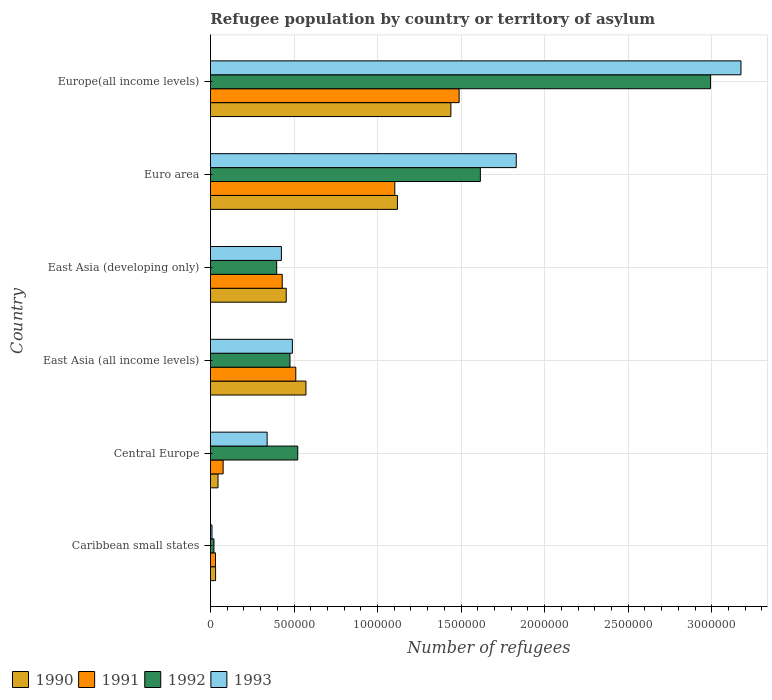Are the number of bars on each tick of the Y-axis equal?
Offer a very short reply. Yes. How many bars are there on the 2nd tick from the top?
Give a very brief answer. 4. What is the label of the 1st group of bars from the top?
Offer a terse response. Europe(all income levels). What is the number of refugees in 1992 in Caribbean small states?
Your answer should be very brief. 2.09e+04. Across all countries, what is the maximum number of refugees in 1991?
Make the answer very short. 1.49e+06. Across all countries, what is the minimum number of refugees in 1990?
Give a very brief answer. 3.07e+04. In which country was the number of refugees in 1990 maximum?
Keep it short and to the point. Europe(all income levels). In which country was the number of refugees in 1990 minimum?
Give a very brief answer. Caribbean small states. What is the total number of refugees in 1992 in the graph?
Ensure brevity in your answer.  6.02e+06. What is the difference between the number of refugees in 1993 in Central Europe and that in East Asia (all income levels)?
Offer a very short reply. -1.51e+05. What is the difference between the number of refugees in 1992 in Caribbean small states and the number of refugees in 1990 in East Asia (developing only)?
Ensure brevity in your answer.  -4.32e+05. What is the average number of refugees in 1991 per country?
Provide a short and direct response. 6.06e+05. What is the difference between the number of refugees in 1991 and number of refugees in 1993 in East Asia (developing only)?
Provide a short and direct response. 5099. What is the ratio of the number of refugees in 1990 in East Asia (all income levels) to that in Europe(all income levels)?
Your answer should be compact. 0.4. Is the difference between the number of refugees in 1991 in East Asia (developing only) and Euro area greater than the difference between the number of refugees in 1993 in East Asia (developing only) and Euro area?
Offer a very short reply. Yes. What is the difference between the highest and the second highest number of refugees in 1991?
Your answer should be compact. 3.85e+05. What is the difference between the highest and the lowest number of refugees in 1993?
Your answer should be compact. 3.17e+06. Is the sum of the number of refugees in 1993 in Central Europe and East Asia (developing only) greater than the maximum number of refugees in 1991 across all countries?
Provide a succinct answer. No. What does the 1st bar from the bottom in Europe(all income levels) represents?
Give a very brief answer. 1990. How many bars are there?
Provide a short and direct response. 24. Does the graph contain any zero values?
Provide a succinct answer. No. Does the graph contain grids?
Give a very brief answer. Yes. How many legend labels are there?
Offer a very short reply. 4. What is the title of the graph?
Keep it short and to the point. Refugee population by country or territory of asylum. What is the label or title of the X-axis?
Provide a succinct answer. Number of refugees. What is the label or title of the Y-axis?
Your answer should be compact. Country. What is the Number of refugees in 1990 in Caribbean small states?
Provide a succinct answer. 3.07e+04. What is the Number of refugees of 1991 in Caribbean small states?
Offer a terse response. 3.00e+04. What is the Number of refugees in 1992 in Caribbean small states?
Provide a short and direct response. 2.09e+04. What is the Number of refugees of 1993 in Caribbean small states?
Make the answer very short. 9084. What is the Number of refugees in 1990 in Central Europe?
Give a very brief answer. 4.51e+04. What is the Number of refugees in 1991 in Central Europe?
Offer a very short reply. 7.57e+04. What is the Number of refugees in 1992 in Central Europe?
Provide a succinct answer. 5.22e+05. What is the Number of refugees of 1993 in Central Europe?
Ensure brevity in your answer.  3.39e+05. What is the Number of refugees of 1990 in East Asia (all income levels)?
Give a very brief answer. 5.71e+05. What is the Number of refugees in 1991 in East Asia (all income levels)?
Your response must be concise. 5.11e+05. What is the Number of refugees in 1992 in East Asia (all income levels)?
Make the answer very short. 4.76e+05. What is the Number of refugees in 1993 in East Asia (all income levels)?
Your response must be concise. 4.90e+05. What is the Number of refugees in 1990 in East Asia (developing only)?
Provide a succinct answer. 4.53e+05. What is the Number of refugees of 1991 in East Asia (developing only)?
Give a very brief answer. 4.30e+05. What is the Number of refugees of 1992 in East Asia (developing only)?
Give a very brief answer. 3.96e+05. What is the Number of refugees in 1993 in East Asia (developing only)?
Provide a succinct answer. 4.24e+05. What is the Number of refugees of 1990 in Euro area?
Provide a short and direct response. 1.12e+06. What is the Number of refugees in 1991 in Euro area?
Your response must be concise. 1.10e+06. What is the Number of refugees in 1992 in Euro area?
Give a very brief answer. 1.62e+06. What is the Number of refugees in 1993 in Euro area?
Your response must be concise. 1.83e+06. What is the Number of refugees in 1990 in Europe(all income levels)?
Your answer should be compact. 1.44e+06. What is the Number of refugees in 1991 in Europe(all income levels)?
Your response must be concise. 1.49e+06. What is the Number of refugees in 1992 in Europe(all income levels)?
Your response must be concise. 2.99e+06. What is the Number of refugees of 1993 in Europe(all income levels)?
Give a very brief answer. 3.18e+06. Across all countries, what is the maximum Number of refugees of 1990?
Your answer should be very brief. 1.44e+06. Across all countries, what is the maximum Number of refugees of 1991?
Offer a terse response. 1.49e+06. Across all countries, what is the maximum Number of refugees of 1992?
Your response must be concise. 2.99e+06. Across all countries, what is the maximum Number of refugees in 1993?
Make the answer very short. 3.18e+06. Across all countries, what is the minimum Number of refugees in 1990?
Your response must be concise. 3.07e+04. Across all countries, what is the minimum Number of refugees in 1991?
Offer a very short reply. 3.00e+04. Across all countries, what is the minimum Number of refugees in 1992?
Your response must be concise. 2.09e+04. Across all countries, what is the minimum Number of refugees in 1993?
Your answer should be compact. 9084. What is the total Number of refugees in 1990 in the graph?
Offer a very short reply. 3.66e+06. What is the total Number of refugees in 1991 in the graph?
Keep it short and to the point. 3.64e+06. What is the total Number of refugees of 1992 in the graph?
Your answer should be very brief. 6.02e+06. What is the total Number of refugees of 1993 in the graph?
Ensure brevity in your answer.  6.27e+06. What is the difference between the Number of refugees in 1990 in Caribbean small states and that in Central Europe?
Ensure brevity in your answer.  -1.45e+04. What is the difference between the Number of refugees in 1991 in Caribbean small states and that in Central Europe?
Give a very brief answer. -4.58e+04. What is the difference between the Number of refugees in 1992 in Caribbean small states and that in Central Europe?
Your answer should be very brief. -5.02e+05. What is the difference between the Number of refugees of 1993 in Caribbean small states and that in Central Europe?
Provide a succinct answer. -3.30e+05. What is the difference between the Number of refugees of 1990 in Caribbean small states and that in East Asia (all income levels)?
Give a very brief answer. -5.41e+05. What is the difference between the Number of refugees in 1991 in Caribbean small states and that in East Asia (all income levels)?
Give a very brief answer. -4.81e+05. What is the difference between the Number of refugees in 1992 in Caribbean small states and that in East Asia (all income levels)?
Provide a short and direct response. -4.55e+05. What is the difference between the Number of refugees in 1993 in Caribbean small states and that in East Asia (all income levels)?
Your answer should be very brief. -4.81e+05. What is the difference between the Number of refugees of 1990 in Caribbean small states and that in East Asia (developing only)?
Offer a very short reply. -4.23e+05. What is the difference between the Number of refugees in 1991 in Caribbean small states and that in East Asia (developing only)?
Your response must be concise. -4.00e+05. What is the difference between the Number of refugees of 1992 in Caribbean small states and that in East Asia (developing only)?
Your answer should be compact. -3.75e+05. What is the difference between the Number of refugees in 1993 in Caribbean small states and that in East Asia (developing only)?
Your response must be concise. -4.15e+05. What is the difference between the Number of refugees of 1990 in Caribbean small states and that in Euro area?
Ensure brevity in your answer.  -1.09e+06. What is the difference between the Number of refugees of 1991 in Caribbean small states and that in Euro area?
Your answer should be compact. -1.07e+06. What is the difference between the Number of refugees of 1992 in Caribbean small states and that in Euro area?
Give a very brief answer. -1.59e+06. What is the difference between the Number of refugees of 1993 in Caribbean small states and that in Euro area?
Keep it short and to the point. -1.82e+06. What is the difference between the Number of refugees in 1990 in Caribbean small states and that in Europe(all income levels)?
Provide a succinct answer. -1.41e+06. What is the difference between the Number of refugees in 1991 in Caribbean small states and that in Europe(all income levels)?
Your response must be concise. -1.46e+06. What is the difference between the Number of refugees in 1992 in Caribbean small states and that in Europe(all income levels)?
Keep it short and to the point. -2.97e+06. What is the difference between the Number of refugees in 1993 in Caribbean small states and that in Europe(all income levels)?
Ensure brevity in your answer.  -3.17e+06. What is the difference between the Number of refugees of 1990 in Central Europe and that in East Asia (all income levels)?
Give a very brief answer. -5.26e+05. What is the difference between the Number of refugees of 1991 in Central Europe and that in East Asia (all income levels)?
Your answer should be compact. -4.35e+05. What is the difference between the Number of refugees in 1992 in Central Europe and that in East Asia (all income levels)?
Offer a very short reply. 4.66e+04. What is the difference between the Number of refugees in 1993 in Central Europe and that in East Asia (all income levels)?
Ensure brevity in your answer.  -1.51e+05. What is the difference between the Number of refugees in 1990 in Central Europe and that in East Asia (developing only)?
Offer a very short reply. -4.08e+05. What is the difference between the Number of refugees of 1991 in Central Europe and that in East Asia (developing only)?
Your answer should be very brief. -3.54e+05. What is the difference between the Number of refugees of 1992 in Central Europe and that in East Asia (developing only)?
Offer a terse response. 1.26e+05. What is the difference between the Number of refugees of 1993 in Central Europe and that in East Asia (developing only)?
Ensure brevity in your answer.  -8.53e+04. What is the difference between the Number of refugees in 1990 in Central Europe and that in Euro area?
Ensure brevity in your answer.  -1.07e+06. What is the difference between the Number of refugees in 1991 in Central Europe and that in Euro area?
Your response must be concise. -1.03e+06. What is the difference between the Number of refugees of 1992 in Central Europe and that in Euro area?
Your answer should be compact. -1.09e+06. What is the difference between the Number of refugees of 1993 in Central Europe and that in Euro area?
Your response must be concise. -1.49e+06. What is the difference between the Number of refugees of 1990 in Central Europe and that in Europe(all income levels)?
Offer a terse response. -1.39e+06. What is the difference between the Number of refugees in 1991 in Central Europe and that in Europe(all income levels)?
Your answer should be very brief. -1.41e+06. What is the difference between the Number of refugees of 1992 in Central Europe and that in Europe(all income levels)?
Make the answer very short. -2.47e+06. What is the difference between the Number of refugees in 1993 in Central Europe and that in Europe(all income levels)?
Keep it short and to the point. -2.84e+06. What is the difference between the Number of refugees of 1990 in East Asia (all income levels) and that in East Asia (developing only)?
Provide a short and direct response. 1.18e+05. What is the difference between the Number of refugees of 1991 in East Asia (all income levels) and that in East Asia (developing only)?
Your answer should be very brief. 8.11e+04. What is the difference between the Number of refugees in 1992 in East Asia (all income levels) and that in East Asia (developing only)?
Your answer should be very brief. 7.95e+04. What is the difference between the Number of refugees in 1993 in East Asia (all income levels) and that in East Asia (developing only)?
Offer a very short reply. 6.58e+04. What is the difference between the Number of refugees of 1990 in East Asia (all income levels) and that in Euro area?
Make the answer very short. -5.48e+05. What is the difference between the Number of refugees in 1991 in East Asia (all income levels) and that in Euro area?
Ensure brevity in your answer.  -5.93e+05. What is the difference between the Number of refugees in 1992 in East Asia (all income levels) and that in Euro area?
Your response must be concise. -1.14e+06. What is the difference between the Number of refugees in 1993 in East Asia (all income levels) and that in Euro area?
Give a very brief answer. -1.34e+06. What is the difference between the Number of refugees in 1990 in East Asia (all income levels) and that in Europe(all income levels)?
Ensure brevity in your answer.  -8.68e+05. What is the difference between the Number of refugees in 1991 in East Asia (all income levels) and that in Europe(all income levels)?
Provide a short and direct response. -9.78e+05. What is the difference between the Number of refugees of 1992 in East Asia (all income levels) and that in Europe(all income levels)?
Your answer should be compact. -2.52e+06. What is the difference between the Number of refugees of 1993 in East Asia (all income levels) and that in Europe(all income levels)?
Your response must be concise. -2.68e+06. What is the difference between the Number of refugees in 1990 in East Asia (developing only) and that in Euro area?
Provide a short and direct response. -6.66e+05. What is the difference between the Number of refugees of 1991 in East Asia (developing only) and that in Euro area?
Provide a succinct answer. -6.74e+05. What is the difference between the Number of refugees in 1992 in East Asia (developing only) and that in Euro area?
Give a very brief answer. -1.22e+06. What is the difference between the Number of refugees in 1993 in East Asia (developing only) and that in Euro area?
Your response must be concise. -1.41e+06. What is the difference between the Number of refugees of 1990 in East Asia (developing only) and that in Europe(all income levels)?
Provide a succinct answer. -9.86e+05. What is the difference between the Number of refugees in 1991 in East Asia (developing only) and that in Europe(all income levels)?
Your answer should be compact. -1.06e+06. What is the difference between the Number of refugees of 1992 in East Asia (developing only) and that in Europe(all income levels)?
Provide a short and direct response. -2.60e+06. What is the difference between the Number of refugees in 1993 in East Asia (developing only) and that in Europe(all income levels)?
Offer a terse response. -2.75e+06. What is the difference between the Number of refugees of 1990 in Euro area and that in Europe(all income levels)?
Your response must be concise. -3.20e+05. What is the difference between the Number of refugees of 1991 in Euro area and that in Europe(all income levels)?
Your answer should be compact. -3.85e+05. What is the difference between the Number of refugees in 1992 in Euro area and that in Europe(all income levels)?
Your answer should be very brief. -1.38e+06. What is the difference between the Number of refugees in 1993 in Euro area and that in Europe(all income levels)?
Ensure brevity in your answer.  -1.34e+06. What is the difference between the Number of refugees of 1990 in Caribbean small states and the Number of refugees of 1991 in Central Europe?
Offer a very short reply. -4.51e+04. What is the difference between the Number of refugees of 1990 in Caribbean small states and the Number of refugees of 1992 in Central Europe?
Ensure brevity in your answer.  -4.92e+05. What is the difference between the Number of refugees of 1990 in Caribbean small states and the Number of refugees of 1993 in Central Europe?
Your answer should be very brief. -3.09e+05. What is the difference between the Number of refugees of 1991 in Caribbean small states and the Number of refugees of 1992 in Central Europe?
Keep it short and to the point. -4.92e+05. What is the difference between the Number of refugees in 1991 in Caribbean small states and the Number of refugees in 1993 in Central Europe?
Your response must be concise. -3.09e+05. What is the difference between the Number of refugees in 1992 in Caribbean small states and the Number of refugees in 1993 in Central Europe?
Provide a succinct answer. -3.18e+05. What is the difference between the Number of refugees of 1990 in Caribbean small states and the Number of refugees of 1991 in East Asia (all income levels)?
Your answer should be compact. -4.80e+05. What is the difference between the Number of refugees of 1990 in Caribbean small states and the Number of refugees of 1992 in East Asia (all income levels)?
Offer a terse response. -4.45e+05. What is the difference between the Number of refugees in 1990 in Caribbean small states and the Number of refugees in 1993 in East Asia (all income levels)?
Give a very brief answer. -4.60e+05. What is the difference between the Number of refugees of 1991 in Caribbean small states and the Number of refugees of 1992 in East Asia (all income levels)?
Your answer should be compact. -4.46e+05. What is the difference between the Number of refugees in 1991 in Caribbean small states and the Number of refugees in 1993 in East Asia (all income levels)?
Your answer should be compact. -4.60e+05. What is the difference between the Number of refugees of 1992 in Caribbean small states and the Number of refugees of 1993 in East Asia (all income levels)?
Your answer should be compact. -4.69e+05. What is the difference between the Number of refugees of 1990 in Caribbean small states and the Number of refugees of 1991 in East Asia (developing only)?
Your answer should be compact. -3.99e+05. What is the difference between the Number of refugees in 1990 in Caribbean small states and the Number of refugees in 1992 in East Asia (developing only)?
Your response must be concise. -3.66e+05. What is the difference between the Number of refugees in 1990 in Caribbean small states and the Number of refugees in 1993 in East Asia (developing only)?
Ensure brevity in your answer.  -3.94e+05. What is the difference between the Number of refugees in 1991 in Caribbean small states and the Number of refugees in 1992 in East Asia (developing only)?
Offer a very short reply. -3.66e+05. What is the difference between the Number of refugees in 1991 in Caribbean small states and the Number of refugees in 1993 in East Asia (developing only)?
Make the answer very short. -3.94e+05. What is the difference between the Number of refugees in 1992 in Caribbean small states and the Number of refugees in 1993 in East Asia (developing only)?
Keep it short and to the point. -4.04e+05. What is the difference between the Number of refugees in 1990 in Caribbean small states and the Number of refugees in 1991 in Euro area?
Your answer should be very brief. -1.07e+06. What is the difference between the Number of refugees in 1990 in Caribbean small states and the Number of refugees in 1992 in Euro area?
Offer a very short reply. -1.58e+06. What is the difference between the Number of refugees in 1990 in Caribbean small states and the Number of refugees in 1993 in Euro area?
Offer a terse response. -1.80e+06. What is the difference between the Number of refugees of 1991 in Caribbean small states and the Number of refugees of 1992 in Euro area?
Your answer should be compact. -1.59e+06. What is the difference between the Number of refugees of 1991 in Caribbean small states and the Number of refugees of 1993 in Euro area?
Keep it short and to the point. -1.80e+06. What is the difference between the Number of refugees in 1992 in Caribbean small states and the Number of refugees in 1993 in Euro area?
Ensure brevity in your answer.  -1.81e+06. What is the difference between the Number of refugees in 1990 in Caribbean small states and the Number of refugees in 1991 in Europe(all income levels)?
Provide a succinct answer. -1.46e+06. What is the difference between the Number of refugees of 1990 in Caribbean small states and the Number of refugees of 1992 in Europe(all income levels)?
Offer a very short reply. -2.96e+06. What is the difference between the Number of refugees of 1990 in Caribbean small states and the Number of refugees of 1993 in Europe(all income levels)?
Your response must be concise. -3.14e+06. What is the difference between the Number of refugees in 1991 in Caribbean small states and the Number of refugees in 1992 in Europe(all income levels)?
Offer a very short reply. -2.96e+06. What is the difference between the Number of refugees in 1991 in Caribbean small states and the Number of refugees in 1993 in Europe(all income levels)?
Your answer should be very brief. -3.15e+06. What is the difference between the Number of refugees in 1992 in Caribbean small states and the Number of refugees in 1993 in Europe(all income levels)?
Your answer should be very brief. -3.15e+06. What is the difference between the Number of refugees in 1990 in Central Europe and the Number of refugees in 1991 in East Asia (all income levels)?
Ensure brevity in your answer.  -4.66e+05. What is the difference between the Number of refugees of 1990 in Central Europe and the Number of refugees of 1992 in East Asia (all income levels)?
Make the answer very short. -4.31e+05. What is the difference between the Number of refugees in 1990 in Central Europe and the Number of refugees in 1993 in East Asia (all income levels)?
Make the answer very short. -4.45e+05. What is the difference between the Number of refugees of 1991 in Central Europe and the Number of refugees of 1992 in East Asia (all income levels)?
Offer a very short reply. -4.00e+05. What is the difference between the Number of refugees of 1991 in Central Europe and the Number of refugees of 1993 in East Asia (all income levels)?
Make the answer very short. -4.15e+05. What is the difference between the Number of refugees in 1992 in Central Europe and the Number of refugees in 1993 in East Asia (all income levels)?
Make the answer very short. 3.21e+04. What is the difference between the Number of refugees in 1990 in Central Europe and the Number of refugees in 1991 in East Asia (developing only)?
Make the answer very short. -3.84e+05. What is the difference between the Number of refugees in 1990 in Central Europe and the Number of refugees in 1992 in East Asia (developing only)?
Your answer should be very brief. -3.51e+05. What is the difference between the Number of refugees of 1990 in Central Europe and the Number of refugees of 1993 in East Asia (developing only)?
Keep it short and to the point. -3.79e+05. What is the difference between the Number of refugees of 1991 in Central Europe and the Number of refugees of 1992 in East Asia (developing only)?
Provide a short and direct response. -3.21e+05. What is the difference between the Number of refugees of 1991 in Central Europe and the Number of refugees of 1993 in East Asia (developing only)?
Your response must be concise. -3.49e+05. What is the difference between the Number of refugees in 1992 in Central Europe and the Number of refugees in 1993 in East Asia (developing only)?
Keep it short and to the point. 9.79e+04. What is the difference between the Number of refugees of 1990 in Central Europe and the Number of refugees of 1991 in Euro area?
Offer a very short reply. -1.06e+06. What is the difference between the Number of refugees in 1990 in Central Europe and the Number of refugees in 1992 in Euro area?
Your answer should be compact. -1.57e+06. What is the difference between the Number of refugees in 1990 in Central Europe and the Number of refugees in 1993 in Euro area?
Provide a short and direct response. -1.78e+06. What is the difference between the Number of refugees in 1991 in Central Europe and the Number of refugees in 1992 in Euro area?
Make the answer very short. -1.54e+06. What is the difference between the Number of refugees of 1991 in Central Europe and the Number of refugees of 1993 in Euro area?
Make the answer very short. -1.75e+06. What is the difference between the Number of refugees of 1992 in Central Europe and the Number of refugees of 1993 in Euro area?
Ensure brevity in your answer.  -1.31e+06. What is the difference between the Number of refugees of 1990 in Central Europe and the Number of refugees of 1991 in Europe(all income levels)?
Provide a short and direct response. -1.44e+06. What is the difference between the Number of refugees of 1990 in Central Europe and the Number of refugees of 1992 in Europe(all income levels)?
Offer a very short reply. -2.95e+06. What is the difference between the Number of refugees in 1990 in Central Europe and the Number of refugees in 1993 in Europe(all income levels)?
Your response must be concise. -3.13e+06. What is the difference between the Number of refugees in 1991 in Central Europe and the Number of refugees in 1992 in Europe(all income levels)?
Provide a succinct answer. -2.92e+06. What is the difference between the Number of refugees in 1991 in Central Europe and the Number of refugees in 1993 in Europe(all income levels)?
Provide a short and direct response. -3.10e+06. What is the difference between the Number of refugees in 1992 in Central Europe and the Number of refugees in 1993 in Europe(all income levels)?
Offer a terse response. -2.65e+06. What is the difference between the Number of refugees of 1990 in East Asia (all income levels) and the Number of refugees of 1991 in East Asia (developing only)?
Your response must be concise. 1.42e+05. What is the difference between the Number of refugees of 1990 in East Asia (all income levels) and the Number of refugees of 1992 in East Asia (developing only)?
Your answer should be very brief. 1.75e+05. What is the difference between the Number of refugees of 1990 in East Asia (all income levels) and the Number of refugees of 1993 in East Asia (developing only)?
Your answer should be very brief. 1.47e+05. What is the difference between the Number of refugees of 1991 in East Asia (all income levels) and the Number of refugees of 1992 in East Asia (developing only)?
Offer a very short reply. 1.14e+05. What is the difference between the Number of refugees of 1991 in East Asia (all income levels) and the Number of refugees of 1993 in East Asia (developing only)?
Your answer should be very brief. 8.62e+04. What is the difference between the Number of refugees of 1992 in East Asia (all income levels) and the Number of refugees of 1993 in East Asia (developing only)?
Provide a succinct answer. 5.14e+04. What is the difference between the Number of refugees of 1990 in East Asia (all income levels) and the Number of refugees of 1991 in Euro area?
Offer a very short reply. -5.32e+05. What is the difference between the Number of refugees in 1990 in East Asia (all income levels) and the Number of refugees in 1992 in Euro area?
Make the answer very short. -1.04e+06. What is the difference between the Number of refugees in 1990 in East Asia (all income levels) and the Number of refugees in 1993 in Euro area?
Ensure brevity in your answer.  -1.26e+06. What is the difference between the Number of refugees in 1991 in East Asia (all income levels) and the Number of refugees in 1992 in Euro area?
Give a very brief answer. -1.10e+06. What is the difference between the Number of refugees of 1991 in East Asia (all income levels) and the Number of refugees of 1993 in Euro area?
Your answer should be compact. -1.32e+06. What is the difference between the Number of refugees in 1992 in East Asia (all income levels) and the Number of refugees in 1993 in Euro area?
Make the answer very short. -1.35e+06. What is the difference between the Number of refugees of 1990 in East Asia (all income levels) and the Number of refugees of 1991 in Europe(all income levels)?
Your answer should be very brief. -9.17e+05. What is the difference between the Number of refugees in 1990 in East Asia (all income levels) and the Number of refugees in 1992 in Europe(all income levels)?
Offer a terse response. -2.42e+06. What is the difference between the Number of refugees of 1990 in East Asia (all income levels) and the Number of refugees of 1993 in Europe(all income levels)?
Provide a short and direct response. -2.60e+06. What is the difference between the Number of refugees of 1991 in East Asia (all income levels) and the Number of refugees of 1992 in Europe(all income levels)?
Offer a terse response. -2.48e+06. What is the difference between the Number of refugees of 1991 in East Asia (all income levels) and the Number of refugees of 1993 in Europe(all income levels)?
Your response must be concise. -2.66e+06. What is the difference between the Number of refugees in 1992 in East Asia (all income levels) and the Number of refugees in 1993 in Europe(all income levels)?
Keep it short and to the point. -2.70e+06. What is the difference between the Number of refugees in 1990 in East Asia (developing only) and the Number of refugees in 1991 in Euro area?
Offer a very short reply. -6.50e+05. What is the difference between the Number of refugees in 1990 in East Asia (developing only) and the Number of refugees in 1992 in Euro area?
Keep it short and to the point. -1.16e+06. What is the difference between the Number of refugees of 1990 in East Asia (developing only) and the Number of refugees of 1993 in Euro area?
Keep it short and to the point. -1.38e+06. What is the difference between the Number of refugees of 1991 in East Asia (developing only) and the Number of refugees of 1992 in Euro area?
Provide a short and direct response. -1.19e+06. What is the difference between the Number of refugees in 1991 in East Asia (developing only) and the Number of refugees in 1993 in Euro area?
Give a very brief answer. -1.40e+06. What is the difference between the Number of refugees in 1992 in East Asia (developing only) and the Number of refugees in 1993 in Euro area?
Make the answer very short. -1.43e+06. What is the difference between the Number of refugees of 1990 in East Asia (developing only) and the Number of refugees of 1991 in Europe(all income levels)?
Your response must be concise. -1.03e+06. What is the difference between the Number of refugees in 1990 in East Asia (developing only) and the Number of refugees in 1992 in Europe(all income levels)?
Provide a succinct answer. -2.54e+06. What is the difference between the Number of refugees of 1990 in East Asia (developing only) and the Number of refugees of 1993 in Europe(all income levels)?
Ensure brevity in your answer.  -2.72e+06. What is the difference between the Number of refugees in 1991 in East Asia (developing only) and the Number of refugees in 1992 in Europe(all income levels)?
Give a very brief answer. -2.56e+06. What is the difference between the Number of refugees of 1991 in East Asia (developing only) and the Number of refugees of 1993 in Europe(all income levels)?
Your response must be concise. -2.75e+06. What is the difference between the Number of refugees in 1992 in East Asia (developing only) and the Number of refugees in 1993 in Europe(all income levels)?
Provide a succinct answer. -2.78e+06. What is the difference between the Number of refugees in 1990 in Euro area and the Number of refugees in 1991 in Europe(all income levels)?
Offer a terse response. -3.69e+05. What is the difference between the Number of refugees of 1990 in Euro area and the Number of refugees of 1992 in Europe(all income levels)?
Make the answer very short. -1.87e+06. What is the difference between the Number of refugees in 1990 in Euro area and the Number of refugees in 1993 in Europe(all income levels)?
Your response must be concise. -2.06e+06. What is the difference between the Number of refugees of 1991 in Euro area and the Number of refugees of 1992 in Europe(all income levels)?
Offer a very short reply. -1.89e+06. What is the difference between the Number of refugees in 1991 in Euro area and the Number of refugees in 1993 in Europe(all income levels)?
Your answer should be very brief. -2.07e+06. What is the difference between the Number of refugees of 1992 in Euro area and the Number of refugees of 1993 in Europe(all income levels)?
Keep it short and to the point. -1.56e+06. What is the average Number of refugees in 1990 per country?
Make the answer very short. 6.10e+05. What is the average Number of refugees in 1991 per country?
Keep it short and to the point. 6.06e+05. What is the average Number of refugees in 1992 per country?
Give a very brief answer. 1.00e+06. What is the average Number of refugees of 1993 per country?
Make the answer very short. 1.04e+06. What is the difference between the Number of refugees in 1990 and Number of refugees in 1991 in Caribbean small states?
Offer a terse response. 684. What is the difference between the Number of refugees in 1990 and Number of refugees in 1992 in Caribbean small states?
Your answer should be very brief. 9790. What is the difference between the Number of refugees in 1990 and Number of refugees in 1993 in Caribbean small states?
Keep it short and to the point. 2.16e+04. What is the difference between the Number of refugees of 1991 and Number of refugees of 1992 in Caribbean small states?
Ensure brevity in your answer.  9106. What is the difference between the Number of refugees of 1991 and Number of refugees of 1993 in Caribbean small states?
Offer a very short reply. 2.09e+04. What is the difference between the Number of refugees of 1992 and Number of refugees of 1993 in Caribbean small states?
Provide a succinct answer. 1.18e+04. What is the difference between the Number of refugees in 1990 and Number of refugees in 1991 in Central Europe?
Your answer should be very brief. -3.06e+04. What is the difference between the Number of refugees of 1990 and Number of refugees of 1992 in Central Europe?
Give a very brief answer. -4.77e+05. What is the difference between the Number of refugees of 1990 and Number of refugees of 1993 in Central Europe?
Make the answer very short. -2.94e+05. What is the difference between the Number of refugees of 1991 and Number of refugees of 1992 in Central Europe?
Make the answer very short. -4.47e+05. What is the difference between the Number of refugees of 1991 and Number of refugees of 1993 in Central Europe?
Offer a terse response. -2.63e+05. What is the difference between the Number of refugees in 1992 and Number of refugees in 1993 in Central Europe?
Ensure brevity in your answer.  1.83e+05. What is the difference between the Number of refugees in 1990 and Number of refugees in 1991 in East Asia (all income levels)?
Give a very brief answer. 6.08e+04. What is the difference between the Number of refugees of 1990 and Number of refugees of 1992 in East Asia (all income levels)?
Your response must be concise. 9.57e+04. What is the difference between the Number of refugees of 1990 and Number of refugees of 1993 in East Asia (all income levels)?
Give a very brief answer. 8.12e+04. What is the difference between the Number of refugees of 1991 and Number of refugees of 1992 in East Asia (all income levels)?
Offer a very short reply. 3.49e+04. What is the difference between the Number of refugees of 1991 and Number of refugees of 1993 in East Asia (all income levels)?
Keep it short and to the point. 2.04e+04. What is the difference between the Number of refugees of 1992 and Number of refugees of 1993 in East Asia (all income levels)?
Ensure brevity in your answer.  -1.44e+04. What is the difference between the Number of refugees in 1990 and Number of refugees in 1991 in East Asia (developing only)?
Ensure brevity in your answer.  2.38e+04. What is the difference between the Number of refugees of 1990 and Number of refugees of 1992 in East Asia (developing only)?
Ensure brevity in your answer.  5.70e+04. What is the difference between the Number of refugees of 1990 and Number of refugees of 1993 in East Asia (developing only)?
Offer a terse response. 2.89e+04. What is the difference between the Number of refugees in 1991 and Number of refugees in 1992 in East Asia (developing only)?
Offer a terse response. 3.32e+04. What is the difference between the Number of refugees of 1991 and Number of refugees of 1993 in East Asia (developing only)?
Make the answer very short. 5099. What is the difference between the Number of refugees in 1992 and Number of refugees in 1993 in East Asia (developing only)?
Provide a short and direct response. -2.81e+04. What is the difference between the Number of refugees in 1990 and Number of refugees in 1991 in Euro area?
Your response must be concise. 1.58e+04. What is the difference between the Number of refugees of 1990 and Number of refugees of 1992 in Euro area?
Ensure brevity in your answer.  -4.96e+05. What is the difference between the Number of refugees of 1990 and Number of refugees of 1993 in Euro area?
Your answer should be compact. -7.11e+05. What is the difference between the Number of refugees in 1991 and Number of refugees in 1992 in Euro area?
Provide a short and direct response. -5.12e+05. What is the difference between the Number of refugees of 1991 and Number of refugees of 1993 in Euro area?
Give a very brief answer. -7.27e+05. What is the difference between the Number of refugees in 1992 and Number of refugees in 1993 in Euro area?
Offer a very short reply. -2.15e+05. What is the difference between the Number of refugees in 1990 and Number of refugees in 1991 in Europe(all income levels)?
Offer a terse response. -4.92e+04. What is the difference between the Number of refugees of 1990 and Number of refugees of 1992 in Europe(all income levels)?
Make the answer very short. -1.55e+06. What is the difference between the Number of refugees in 1990 and Number of refugees in 1993 in Europe(all income levels)?
Offer a very short reply. -1.74e+06. What is the difference between the Number of refugees of 1991 and Number of refugees of 1992 in Europe(all income levels)?
Your answer should be compact. -1.50e+06. What is the difference between the Number of refugees of 1991 and Number of refugees of 1993 in Europe(all income levels)?
Make the answer very short. -1.69e+06. What is the difference between the Number of refugees of 1992 and Number of refugees of 1993 in Europe(all income levels)?
Ensure brevity in your answer.  -1.82e+05. What is the ratio of the Number of refugees of 1990 in Caribbean small states to that in Central Europe?
Ensure brevity in your answer.  0.68. What is the ratio of the Number of refugees of 1991 in Caribbean small states to that in Central Europe?
Give a very brief answer. 0.4. What is the ratio of the Number of refugees in 1992 in Caribbean small states to that in Central Europe?
Your answer should be very brief. 0.04. What is the ratio of the Number of refugees in 1993 in Caribbean small states to that in Central Europe?
Your answer should be compact. 0.03. What is the ratio of the Number of refugees of 1990 in Caribbean small states to that in East Asia (all income levels)?
Offer a terse response. 0.05. What is the ratio of the Number of refugees of 1991 in Caribbean small states to that in East Asia (all income levels)?
Your response must be concise. 0.06. What is the ratio of the Number of refugees of 1992 in Caribbean small states to that in East Asia (all income levels)?
Your answer should be compact. 0.04. What is the ratio of the Number of refugees in 1993 in Caribbean small states to that in East Asia (all income levels)?
Give a very brief answer. 0.02. What is the ratio of the Number of refugees of 1990 in Caribbean small states to that in East Asia (developing only)?
Your answer should be compact. 0.07. What is the ratio of the Number of refugees of 1991 in Caribbean small states to that in East Asia (developing only)?
Offer a very short reply. 0.07. What is the ratio of the Number of refugees of 1992 in Caribbean small states to that in East Asia (developing only)?
Make the answer very short. 0.05. What is the ratio of the Number of refugees in 1993 in Caribbean small states to that in East Asia (developing only)?
Give a very brief answer. 0.02. What is the ratio of the Number of refugees in 1990 in Caribbean small states to that in Euro area?
Your answer should be compact. 0.03. What is the ratio of the Number of refugees in 1991 in Caribbean small states to that in Euro area?
Your response must be concise. 0.03. What is the ratio of the Number of refugees in 1992 in Caribbean small states to that in Euro area?
Make the answer very short. 0.01. What is the ratio of the Number of refugees of 1993 in Caribbean small states to that in Euro area?
Your answer should be compact. 0.01. What is the ratio of the Number of refugees of 1990 in Caribbean small states to that in Europe(all income levels)?
Make the answer very short. 0.02. What is the ratio of the Number of refugees in 1991 in Caribbean small states to that in Europe(all income levels)?
Make the answer very short. 0.02. What is the ratio of the Number of refugees of 1992 in Caribbean small states to that in Europe(all income levels)?
Give a very brief answer. 0.01. What is the ratio of the Number of refugees in 1993 in Caribbean small states to that in Europe(all income levels)?
Ensure brevity in your answer.  0. What is the ratio of the Number of refugees of 1990 in Central Europe to that in East Asia (all income levels)?
Make the answer very short. 0.08. What is the ratio of the Number of refugees of 1991 in Central Europe to that in East Asia (all income levels)?
Offer a very short reply. 0.15. What is the ratio of the Number of refugees in 1992 in Central Europe to that in East Asia (all income levels)?
Your response must be concise. 1.1. What is the ratio of the Number of refugees in 1993 in Central Europe to that in East Asia (all income levels)?
Offer a very short reply. 0.69. What is the ratio of the Number of refugees in 1990 in Central Europe to that in East Asia (developing only)?
Ensure brevity in your answer.  0.1. What is the ratio of the Number of refugees of 1991 in Central Europe to that in East Asia (developing only)?
Your answer should be very brief. 0.18. What is the ratio of the Number of refugees of 1992 in Central Europe to that in East Asia (developing only)?
Ensure brevity in your answer.  1.32. What is the ratio of the Number of refugees in 1993 in Central Europe to that in East Asia (developing only)?
Your answer should be compact. 0.8. What is the ratio of the Number of refugees of 1990 in Central Europe to that in Euro area?
Ensure brevity in your answer.  0.04. What is the ratio of the Number of refugees in 1991 in Central Europe to that in Euro area?
Offer a terse response. 0.07. What is the ratio of the Number of refugees of 1992 in Central Europe to that in Euro area?
Give a very brief answer. 0.32. What is the ratio of the Number of refugees of 1993 in Central Europe to that in Euro area?
Provide a short and direct response. 0.19. What is the ratio of the Number of refugees of 1990 in Central Europe to that in Europe(all income levels)?
Provide a succinct answer. 0.03. What is the ratio of the Number of refugees of 1991 in Central Europe to that in Europe(all income levels)?
Offer a very short reply. 0.05. What is the ratio of the Number of refugees in 1992 in Central Europe to that in Europe(all income levels)?
Make the answer very short. 0.17. What is the ratio of the Number of refugees of 1993 in Central Europe to that in Europe(all income levels)?
Give a very brief answer. 0.11. What is the ratio of the Number of refugees in 1990 in East Asia (all income levels) to that in East Asia (developing only)?
Provide a short and direct response. 1.26. What is the ratio of the Number of refugees in 1991 in East Asia (all income levels) to that in East Asia (developing only)?
Ensure brevity in your answer.  1.19. What is the ratio of the Number of refugees in 1992 in East Asia (all income levels) to that in East Asia (developing only)?
Your answer should be very brief. 1.2. What is the ratio of the Number of refugees in 1993 in East Asia (all income levels) to that in East Asia (developing only)?
Offer a terse response. 1.16. What is the ratio of the Number of refugees of 1990 in East Asia (all income levels) to that in Euro area?
Provide a short and direct response. 0.51. What is the ratio of the Number of refugees of 1991 in East Asia (all income levels) to that in Euro area?
Provide a succinct answer. 0.46. What is the ratio of the Number of refugees of 1992 in East Asia (all income levels) to that in Euro area?
Offer a very short reply. 0.29. What is the ratio of the Number of refugees of 1993 in East Asia (all income levels) to that in Euro area?
Your response must be concise. 0.27. What is the ratio of the Number of refugees in 1990 in East Asia (all income levels) to that in Europe(all income levels)?
Your answer should be compact. 0.4. What is the ratio of the Number of refugees in 1991 in East Asia (all income levels) to that in Europe(all income levels)?
Keep it short and to the point. 0.34. What is the ratio of the Number of refugees of 1992 in East Asia (all income levels) to that in Europe(all income levels)?
Your response must be concise. 0.16. What is the ratio of the Number of refugees of 1993 in East Asia (all income levels) to that in Europe(all income levels)?
Provide a succinct answer. 0.15. What is the ratio of the Number of refugees of 1990 in East Asia (developing only) to that in Euro area?
Your answer should be very brief. 0.41. What is the ratio of the Number of refugees in 1991 in East Asia (developing only) to that in Euro area?
Your response must be concise. 0.39. What is the ratio of the Number of refugees in 1992 in East Asia (developing only) to that in Euro area?
Keep it short and to the point. 0.25. What is the ratio of the Number of refugees of 1993 in East Asia (developing only) to that in Euro area?
Your response must be concise. 0.23. What is the ratio of the Number of refugees of 1990 in East Asia (developing only) to that in Europe(all income levels)?
Offer a terse response. 0.32. What is the ratio of the Number of refugees of 1991 in East Asia (developing only) to that in Europe(all income levels)?
Give a very brief answer. 0.29. What is the ratio of the Number of refugees of 1992 in East Asia (developing only) to that in Europe(all income levels)?
Provide a short and direct response. 0.13. What is the ratio of the Number of refugees in 1993 in East Asia (developing only) to that in Europe(all income levels)?
Offer a very short reply. 0.13. What is the ratio of the Number of refugees in 1990 in Euro area to that in Europe(all income levels)?
Offer a very short reply. 0.78. What is the ratio of the Number of refugees in 1991 in Euro area to that in Europe(all income levels)?
Offer a terse response. 0.74. What is the ratio of the Number of refugees of 1992 in Euro area to that in Europe(all income levels)?
Give a very brief answer. 0.54. What is the ratio of the Number of refugees in 1993 in Euro area to that in Europe(all income levels)?
Provide a succinct answer. 0.58. What is the difference between the highest and the second highest Number of refugees of 1990?
Provide a succinct answer. 3.20e+05. What is the difference between the highest and the second highest Number of refugees in 1991?
Provide a short and direct response. 3.85e+05. What is the difference between the highest and the second highest Number of refugees of 1992?
Keep it short and to the point. 1.38e+06. What is the difference between the highest and the second highest Number of refugees of 1993?
Provide a short and direct response. 1.34e+06. What is the difference between the highest and the lowest Number of refugees of 1990?
Keep it short and to the point. 1.41e+06. What is the difference between the highest and the lowest Number of refugees of 1991?
Make the answer very short. 1.46e+06. What is the difference between the highest and the lowest Number of refugees of 1992?
Your answer should be very brief. 2.97e+06. What is the difference between the highest and the lowest Number of refugees in 1993?
Keep it short and to the point. 3.17e+06. 